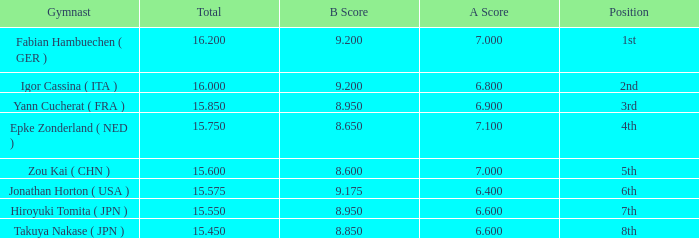What was the total rating that had a score higher than 7 and a b score smaller than 8.65? None. 